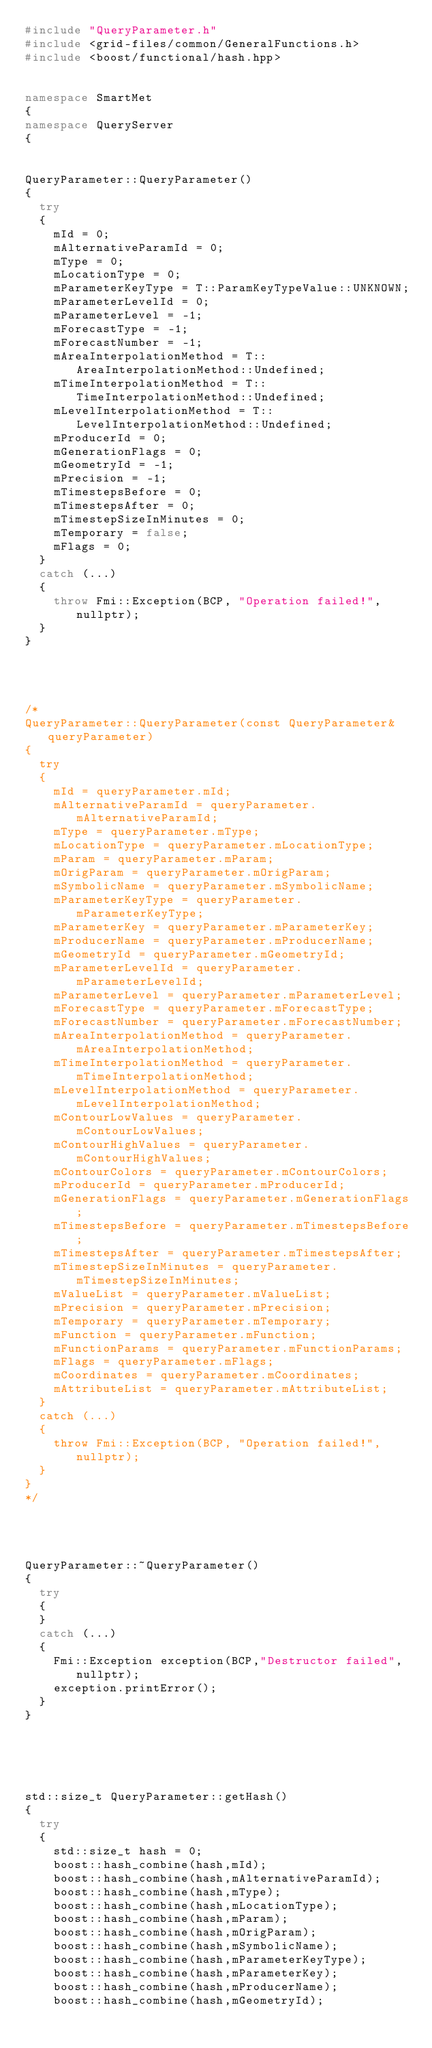Convert code to text. <code><loc_0><loc_0><loc_500><loc_500><_C++_>#include "QueryParameter.h"
#include <grid-files/common/GeneralFunctions.h>
#include <boost/functional/hash.hpp>


namespace SmartMet
{
namespace QueryServer
{


QueryParameter::QueryParameter()
{
  try
  {
    mId = 0;
    mAlternativeParamId = 0;
    mType = 0;
    mLocationType = 0;
    mParameterKeyType = T::ParamKeyTypeValue::UNKNOWN;
    mParameterLevelId = 0;
    mParameterLevel = -1;
    mForecastType = -1;
    mForecastNumber = -1;
    mAreaInterpolationMethod = T::AreaInterpolationMethod::Undefined;
    mTimeInterpolationMethod = T::TimeInterpolationMethod::Undefined;
    mLevelInterpolationMethod = T::LevelInterpolationMethod::Undefined;
    mProducerId = 0;
    mGenerationFlags = 0;
    mGeometryId = -1;
    mPrecision = -1;
    mTimestepsBefore = 0;
    mTimestepsAfter = 0;
    mTimestepSizeInMinutes = 0;
    mTemporary = false;
    mFlags = 0;
  }
  catch (...)
  {
    throw Fmi::Exception(BCP, "Operation failed!", nullptr);
  }
}




/*
QueryParameter::QueryParameter(const QueryParameter& queryParameter)
{
  try
  {
    mId = queryParameter.mId;
    mAlternativeParamId = queryParameter.mAlternativeParamId;
    mType = queryParameter.mType;
    mLocationType = queryParameter.mLocationType;
    mParam = queryParameter.mParam;
    mOrigParam = queryParameter.mOrigParam;
    mSymbolicName = queryParameter.mSymbolicName;
    mParameterKeyType = queryParameter.mParameterKeyType;
    mParameterKey = queryParameter.mParameterKey;
    mProducerName = queryParameter.mProducerName;
    mGeometryId = queryParameter.mGeometryId;
    mParameterLevelId = queryParameter.mParameterLevelId;
    mParameterLevel = queryParameter.mParameterLevel;
    mForecastType = queryParameter.mForecastType;
    mForecastNumber = queryParameter.mForecastNumber;
    mAreaInterpolationMethod = queryParameter.mAreaInterpolationMethod;
    mTimeInterpolationMethod = queryParameter.mTimeInterpolationMethod;
    mLevelInterpolationMethod = queryParameter.mLevelInterpolationMethod;
    mContourLowValues = queryParameter.mContourLowValues;
    mContourHighValues = queryParameter.mContourHighValues;
    mContourColors = queryParameter.mContourColors;
    mProducerId = queryParameter.mProducerId;
    mGenerationFlags = queryParameter.mGenerationFlags;
    mTimestepsBefore = queryParameter.mTimestepsBefore;
    mTimestepsAfter = queryParameter.mTimestepsAfter;
    mTimestepSizeInMinutes = queryParameter.mTimestepSizeInMinutes;
    mValueList = queryParameter.mValueList;
    mPrecision = queryParameter.mPrecision;
    mTemporary = queryParameter.mTemporary;
    mFunction = queryParameter.mFunction;
    mFunctionParams = queryParameter.mFunctionParams;
    mFlags = queryParameter.mFlags;
    mCoordinates = queryParameter.mCoordinates;
    mAttributeList = queryParameter.mAttributeList;
  }
  catch (...)
  {
    throw Fmi::Exception(BCP, "Operation failed!", nullptr);
  }
}
*/




QueryParameter::~QueryParameter()
{
  try
  {
  }
  catch (...)
  {
    Fmi::Exception exception(BCP,"Destructor failed",nullptr);
    exception.printError();
  }
}





std::size_t QueryParameter::getHash()
{
  try
  {
    std::size_t hash = 0;
    boost::hash_combine(hash,mId);
    boost::hash_combine(hash,mAlternativeParamId);
    boost::hash_combine(hash,mType);
    boost::hash_combine(hash,mLocationType);
    boost::hash_combine(hash,mParam);
    boost::hash_combine(hash,mOrigParam);
    boost::hash_combine(hash,mSymbolicName);
    boost::hash_combine(hash,mParameterKeyType);
    boost::hash_combine(hash,mParameterKey);
    boost::hash_combine(hash,mProducerName);
    boost::hash_combine(hash,mGeometryId);</code> 